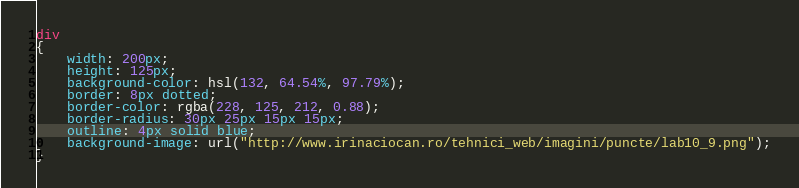Convert code to text. <code><loc_0><loc_0><loc_500><loc_500><_CSS_>div
{
	width: 200px;
	height: 125px;
	background-color: hsl(132, 64.54%, 97.79%);
	border: 8px dotted;
	border-color: rgba(228, 125, 212, 0.88);
	border-radius: 30px 25px 15px 15px;
	outline: 4px solid blue;
	background-image: url("http://www.irinaciocan.ro/tehnici_web/imagini/puncte/lab10_9.png");
}</code> 